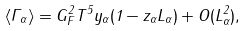<formula> <loc_0><loc_0><loc_500><loc_500>\langle \Gamma _ { \alpha } \rangle = G _ { F } ^ { 2 } T ^ { 5 } y _ { \alpha } ( 1 - z _ { \alpha } L _ { \alpha } ) + O ( L _ { \alpha } ^ { 2 } ) ,</formula> 